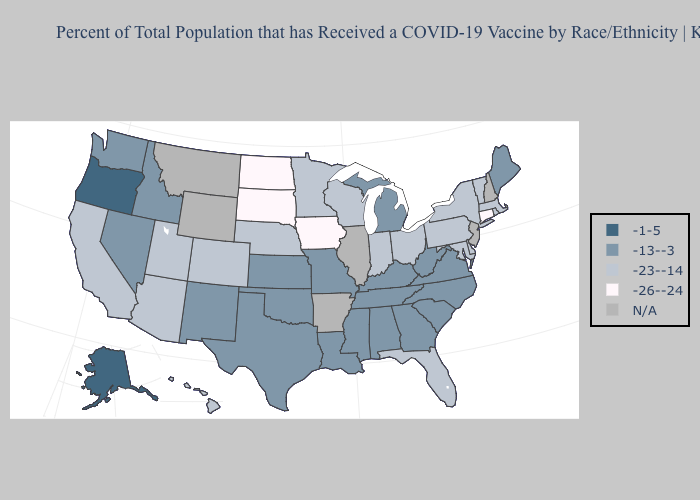What is the value of Rhode Island?
Quick response, please. -23--14. Does Oregon have the highest value in the USA?
Concise answer only. Yes. Does New York have the highest value in the USA?
Answer briefly. No. What is the lowest value in states that border Louisiana?
Concise answer only. -13--3. Is the legend a continuous bar?
Keep it brief. No. What is the highest value in the USA?
Give a very brief answer. -1-5. Which states hav the highest value in the South?
Short answer required. Alabama, Georgia, Kentucky, Louisiana, Mississippi, North Carolina, Oklahoma, South Carolina, Tennessee, Texas, Virginia, West Virginia. What is the lowest value in states that border Delaware?
Answer briefly. -23--14. Which states have the lowest value in the USA?
Give a very brief answer. Connecticut, Iowa, North Dakota, South Dakota. Name the states that have a value in the range -26--24?
Concise answer only. Connecticut, Iowa, North Dakota, South Dakota. Which states have the lowest value in the USA?
Be succinct. Connecticut, Iowa, North Dakota, South Dakota. What is the value of Mississippi?
Short answer required. -13--3. Among the states that border California , does Nevada have the highest value?
Write a very short answer. No. What is the value of Michigan?
Keep it brief. -13--3. 